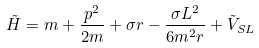Convert formula to latex. <formula><loc_0><loc_0><loc_500><loc_500>\tilde { H } = m + \frac { p ^ { 2 } } { 2 m } + \sigma r - \frac { \sigma L ^ { 2 } } { 6 m ^ { 2 } r } + \tilde { V } _ { S L }</formula> 